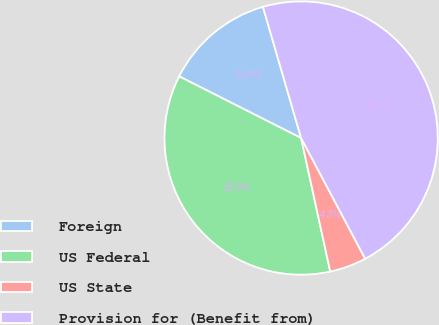<chart> <loc_0><loc_0><loc_500><loc_500><pie_chart><fcel>Foreign<fcel>US Federal<fcel>US State<fcel>Provision for (Benefit from)<nl><fcel>13.04%<fcel>35.87%<fcel>4.35%<fcel>46.74%<nl></chart> 